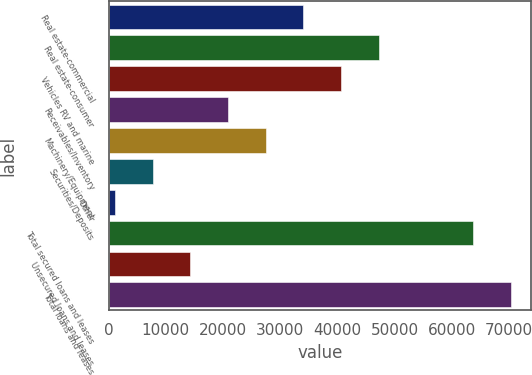Convert chart to OTSL. <chart><loc_0><loc_0><loc_500><loc_500><bar_chart><fcel>Real estate-commercial<fcel>Real estate-consumer<fcel>Vehicles RV and marine<fcel>Receivables/Inventory<fcel>Machinery/Equipment<fcel>Securities/Deposits<fcel>Other<fcel>Total secured loans and leases<fcel>Unsecured loans and leases<fcel>Total loans and leases<nl><fcel>34058<fcel>47219.6<fcel>40638.8<fcel>20896.4<fcel>27477.2<fcel>7734.8<fcel>1154<fcel>63695<fcel>14315.6<fcel>70275.8<nl></chart> 